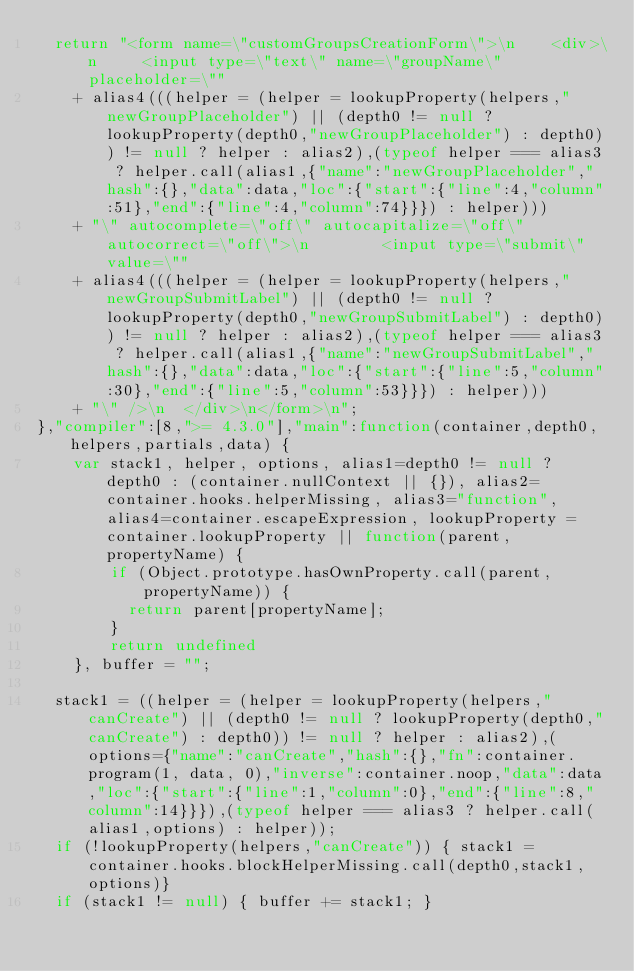Convert code to text. <code><loc_0><loc_0><loc_500><loc_500><_JavaScript_>  return "<form name=\"customGroupsCreationForm\">\n	<div>\n		<input type=\"text\" name=\"groupName\" placeholder=\""
    + alias4(((helper = (helper = lookupProperty(helpers,"newGroupPlaceholder") || (depth0 != null ? lookupProperty(depth0,"newGroupPlaceholder") : depth0)) != null ? helper : alias2),(typeof helper === alias3 ? helper.call(alias1,{"name":"newGroupPlaceholder","hash":{},"data":data,"loc":{"start":{"line":4,"column":51},"end":{"line":4,"column":74}}}) : helper)))
    + "\" autocomplete=\"off\" autocapitalize=\"off\" autocorrect=\"off\">\n		<input type=\"submit\" value=\""
    + alias4(((helper = (helper = lookupProperty(helpers,"newGroupSubmitLabel") || (depth0 != null ? lookupProperty(depth0,"newGroupSubmitLabel") : depth0)) != null ? helper : alias2),(typeof helper === alias3 ? helper.call(alias1,{"name":"newGroupSubmitLabel","hash":{},"data":data,"loc":{"start":{"line":5,"column":30},"end":{"line":5,"column":53}}}) : helper)))
    + "\" />\n	</div>\n</form>\n";
},"compiler":[8,">= 4.3.0"],"main":function(container,depth0,helpers,partials,data) {
    var stack1, helper, options, alias1=depth0 != null ? depth0 : (container.nullContext || {}), alias2=container.hooks.helperMissing, alias3="function", alias4=container.escapeExpression, lookupProperty = container.lookupProperty || function(parent, propertyName) {
        if (Object.prototype.hasOwnProperty.call(parent, propertyName)) {
          return parent[propertyName];
        }
        return undefined
    }, buffer = "";

  stack1 = ((helper = (helper = lookupProperty(helpers,"canCreate") || (depth0 != null ? lookupProperty(depth0,"canCreate") : depth0)) != null ? helper : alias2),(options={"name":"canCreate","hash":{},"fn":container.program(1, data, 0),"inverse":container.noop,"data":data,"loc":{"start":{"line":1,"column":0},"end":{"line":8,"column":14}}}),(typeof helper === alias3 ? helper.call(alias1,options) : helper));
  if (!lookupProperty(helpers,"canCreate")) { stack1 = container.hooks.blockHelperMissing.call(depth0,stack1,options)}
  if (stack1 != null) { buffer += stack1; }</code> 